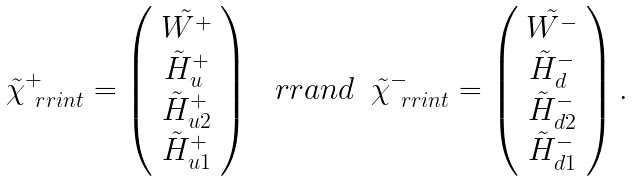Convert formula to latex. <formula><loc_0><loc_0><loc_500><loc_500>\begin{array} { c c c } \tilde { \chi } _ { \ r r { i n t } } ^ { + } = \left ( \begin{array} { c } \tilde { W ^ { + } } \\ \tilde { H } _ { u } ^ { + } \\ \tilde { H } _ { u 2 } ^ { + } \\ \tilde { H } _ { u 1 } ^ { + } \end{array} \right ) & \ r r { a n d } & \tilde { \chi } _ { \ r r { i n t } } ^ { - } = \left ( \begin{array} { c } \tilde { W ^ { - } } \\ \tilde { H } _ { d } ^ { - } \\ \tilde { H } _ { d 2 } ^ { - } \\ \tilde { H } _ { d 1 } ^ { - } \end{array} \right ) . \end{array}</formula> 